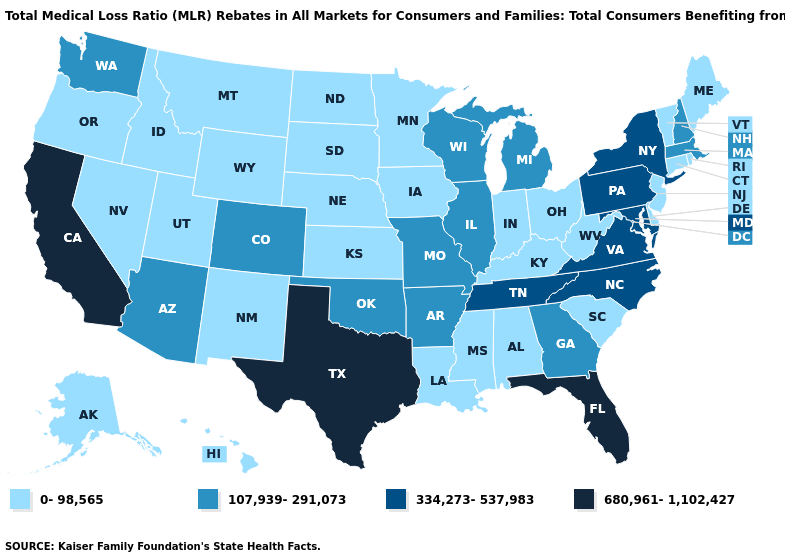What is the value of Louisiana?
Give a very brief answer. 0-98,565. Does Georgia have the lowest value in the USA?
Quick response, please. No. Which states have the highest value in the USA?
Quick response, please. California, Florida, Texas. Which states have the highest value in the USA?
Give a very brief answer. California, Florida, Texas. What is the lowest value in states that border North Carolina?
Give a very brief answer. 0-98,565. What is the highest value in the USA?
Keep it brief. 680,961-1,102,427. Which states hav the highest value in the Northeast?
Give a very brief answer. New York, Pennsylvania. What is the value of Louisiana?
Quick response, please. 0-98,565. Among the states that border New Jersey , which have the lowest value?
Give a very brief answer. Delaware. Which states have the highest value in the USA?
Answer briefly. California, Florida, Texas. Among the states that border Colorado , does Oklahoma have the highest value?
Short answer required. Yes. What is the highest value in states that border Nevada?
Short answer required. 680,961-1,102,427. How many symbols are there in the legend?
Short answer required. 4. Among the states that border Vermont , which have the lowest value?
Quick response, please. Massachusetts, New Hampshire. Name the states that have a value in the range 680,961-1,102,427?
Answer briefly. California, Florida, Texas. 